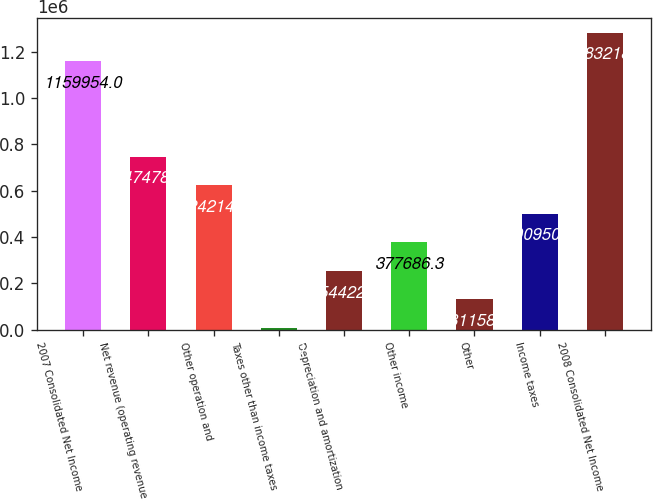Convert chart. <chart><loc_0><loc_0><loc_500><loc_500><bar_chart><fcel>2007 Consolidated Net Income<fcel>Net revenue (operating revenue<fcel>Other operation and<fcel>Taxes other than income taxes<fcel>Depreciation and amortization<fcel>Other income<fcel>Other<fcel>Income taxes<fcel>2008 Consolidated Net Income<nl><fcel>1.15995e+06<fcel>747479<fcel>624214<fcel>7894<fcel>254422<fcel>377686<fcel>131158<fcel>500950<fcel>1.28322e+06<nl></chart> 